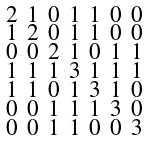Convert formula to latex. <formula><loc_0><loc_0><loc_500><loc_500>\begin{smallmatrix} 2 & 1 & 0 & 1 & 1 & 0 & 0 \\ 1 & 2 & 0 & 1 & 1 & 0 & 0 \\ 0 & 0 & 2 & 1 & 0 & 1 & 1 \\ 1 & 1 & 1 & 3 & 1 & 1 & 1 \\ 1 & 1 & 0 & 1 & 3 & 1 & 0 \\ 0 & 0 & 1 & 1 & 1 & 3 & 0 \\ 0 & 0 & 1 & 1 & 0 & 0 & 3 \end{smallmatrix}</formula> 